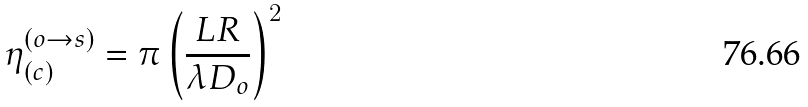<formula> <loc_0><loc_0><loc_500><loc_500>\eta _ { ( c ) } ^ { ( o \rightarrow s ) } = \pi \left ( \frac { L R } { \lambda D _ { o } } \right ) ^ { 2 }</formula> 